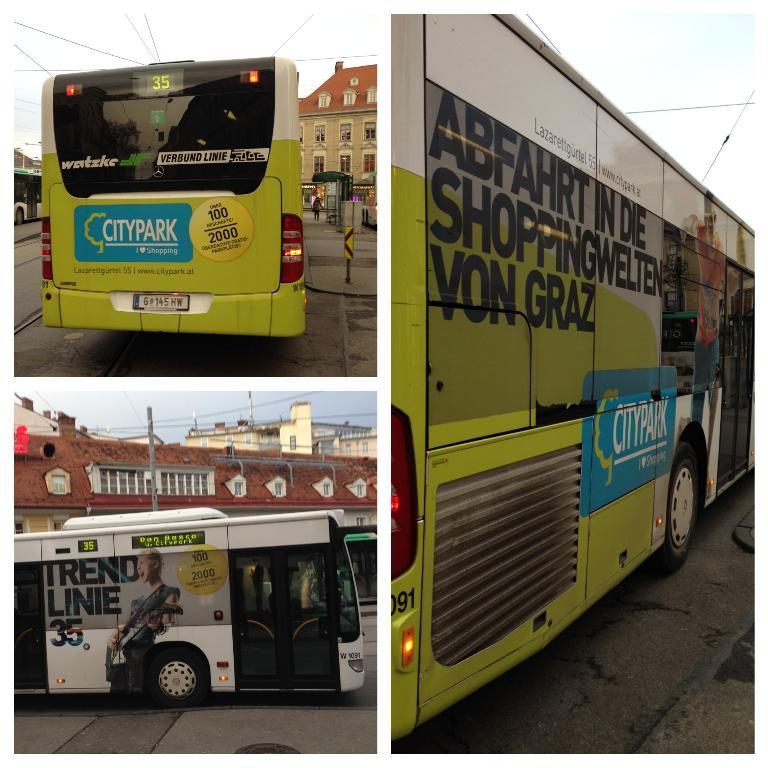What is the main subject of the image? The main subject of the image is a bus. What colors can be seen on the bus? The bus is green, blue, black, and white in color. Where is the bus located in the image? The bus is on the road. What can be seen in the background of the image? There is a building, a pole, wires, and the sky visible in the background of the image. What type of fruit is hanging from the wires in the image? There are no fruits visible in the image; only wires, a pole, and the sky can be seen in the background. 